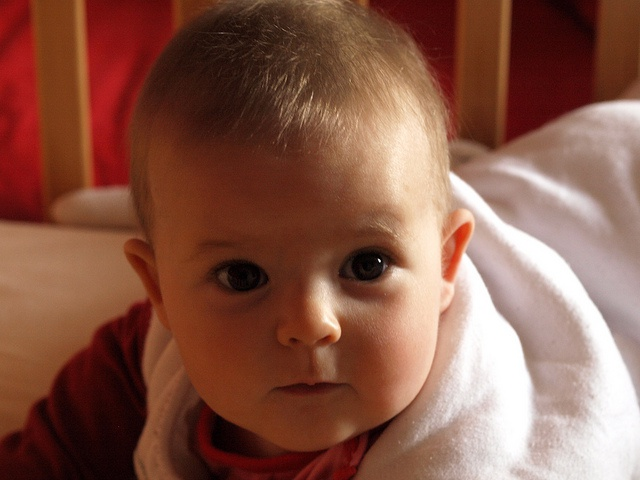Describe the objects in this image and their specific colors. I can see people in maroon, black, white, and darkgray tones and bed in maroon, gray, and brown tones in this image. 